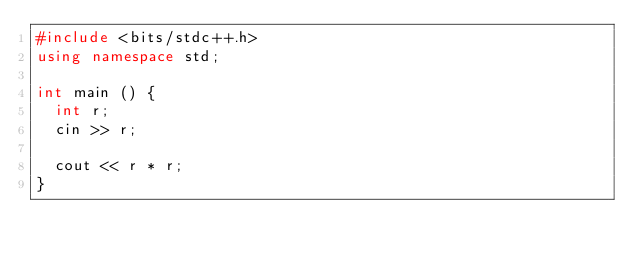Convert code to text. <code><loc_0><loc_0><loc_500><loc_500><_C++_>#include <bits/stdc++.h>
using namespace std;

int main () {
  int r;
  cin >> r;

  cout << r * r;
}</code> 